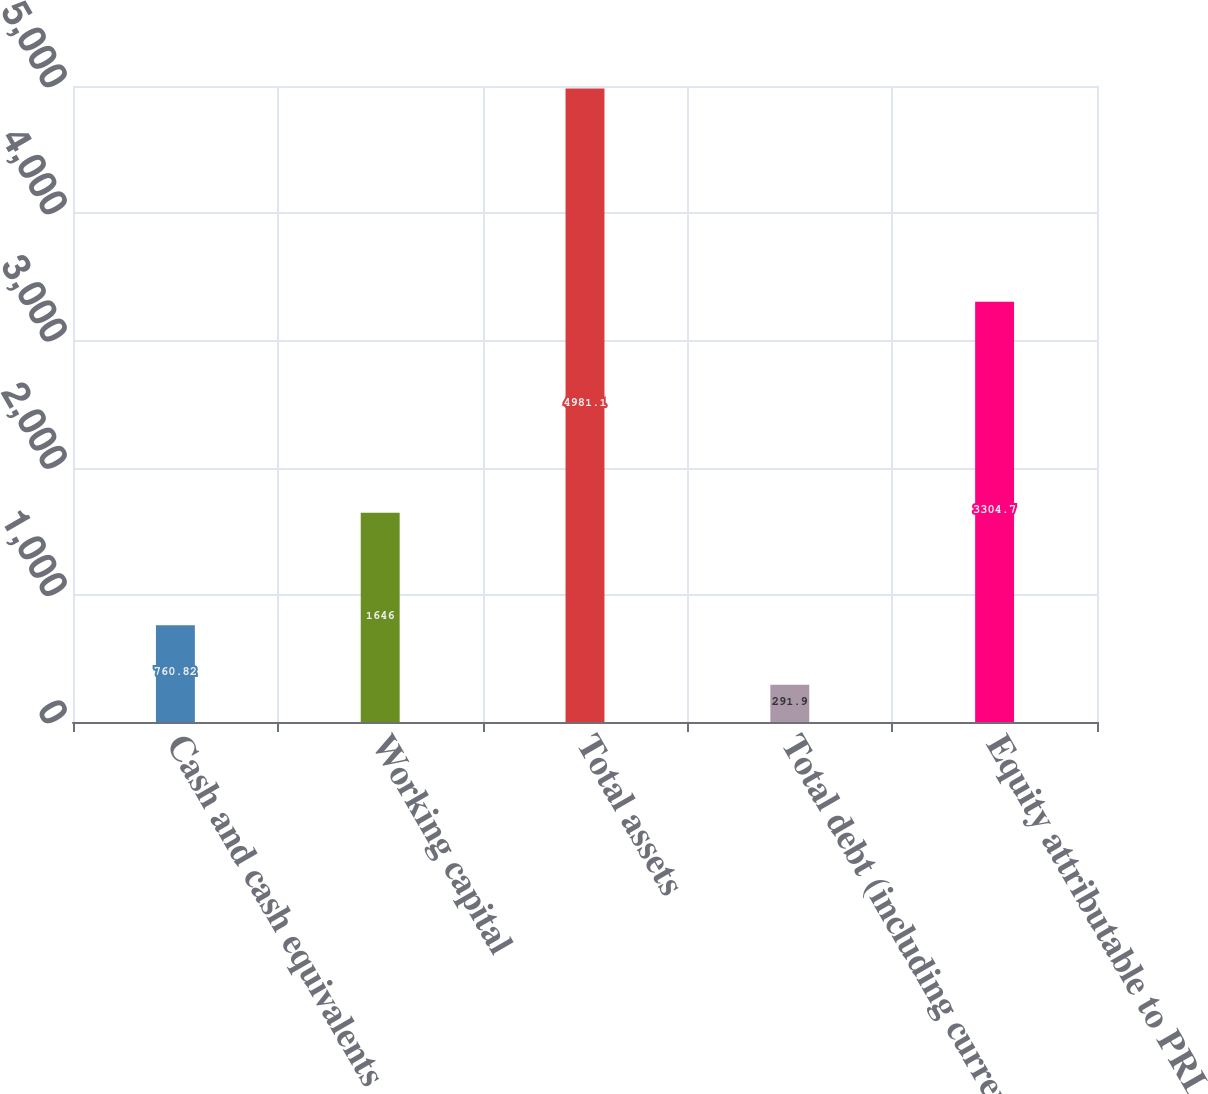Convert chart. <chart><loc_0><loc_0><loc_500><loc_500><bar_chart><fcel>Cash and cash equivalents<fcel>Working capital<fcel>Total assets<fcel>Total debt (including current<fcel>Equity attributable to PRLC<nl><fcel>760.82<fcel>1646<fcel>4981.1<fcel>291.9<fcel>3304.7<nl></chart> 